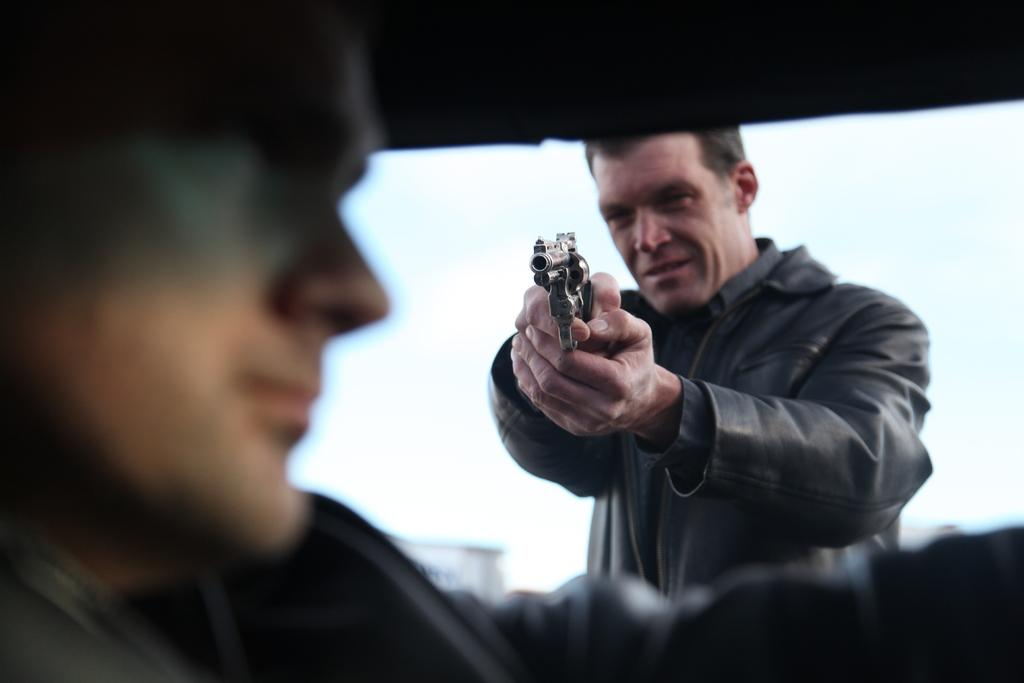What is the person in the image holding? The person is holding a gun in the image. What is the person with the gun doing? The person is pointing the gun at another person. What type of wire is being used to hold the cracker in the image? There is no wire or cracker present in the image; it only features a person holding a gun and pointing it at another person. 